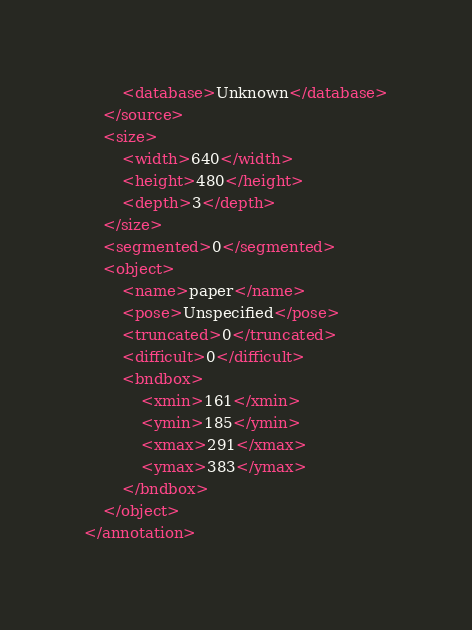<code> <loc_0><loc_0><loc_500><loc_500><_XML_>		<database>Unknown</database>
	</source>
	<size>
		<width>640</width>
		<height>480</height>
		<depth>3</depth>
	</size>
	<segmented>0</segmented>
	<object>
		<name>paper</name>
		<pose>Unspecified</pose>
		<truncated>0</truncated>
		<difficult>0</difficult>
		<bndbox>
			<xmin>161</xmin>
			<ymin>185</ymin>
			<xmax>291</xmax>
			<ymax>383</ymax>
		</bndbox>
	</object>
</annotation>
</code> 